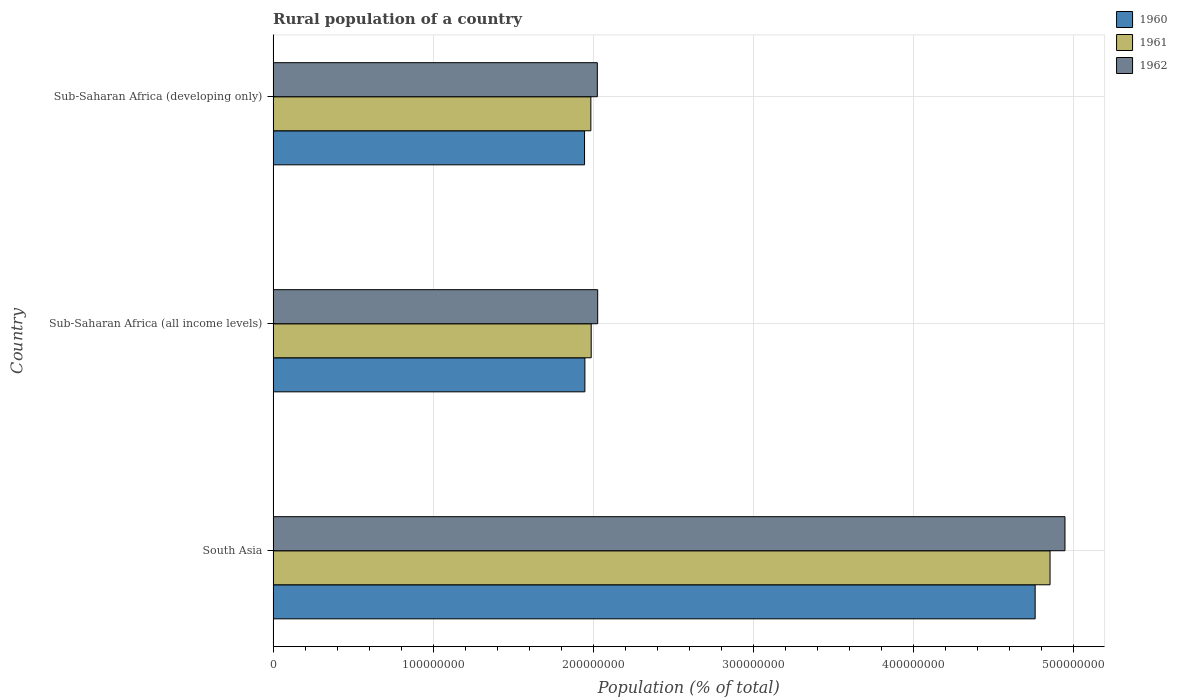How many different coloured bars are there?
Your answer should be very brief. 3. Are the number of bars per tick equal to the number of legend labels?
Offer a terse response. Yes. In how many cases, is the number of bars for a given country not equal to the number of legend labels?
Offer a very short reply. 0. What is the rural population in 1962 in Sub-Saharan Africa (all income levels)?
Keep it short and to the point. 2.03e+08. Across all countries, what is the maximum rural population in 1962?
Give a very brief answer. 4.95e+08. Across all countries, what is the minimum rural population in 1960?
Offer a very short reply. 1.95e+08. In which country was the rural population in 1960 maximum?
Give a very brief answer. South Asia. In which country was the rural population in 1960 minimum?
Your answer should be very brief. Sub-Saharan Africa (developing only). What is the total rural population in 1961 in the graph?
Your answer should be compact. 8.83e+08. What is the difference between the rural population in 1960 in Sub-Saharan Africa (all income levels) and that in Sub-Saharan Africa (developing only)?
Keep it short and to the point. 2.18e+05. What is the difference between the rural population in 1962 in Sub-Saharan Africa (developing only) and the rural population in 1961 in South Asia?
Offer a terse response. -2.83e+08. What is the average rural population in 1962 per country?
Provide a succinct answer. 3.00e+08. What is the difference between the rural population in 1960 and rural population in 1962 in Sub-Saharan Africa (developing only)?
Your response must be concise. -8.00e+06. In how many countries, is the rural population in 1961 greater than 420000000 %?
Offer a terse response. 1. What is the ratio of the rural population in 1960 in South Asia to that in Sub-Saharan Africa (all income levels)?
Make the answer very short. 2.44. What is the difference between the highest and the second highest rural population in 1962?
Keep it short and to the point. 2.92e+08. What is the difference between the highest and the lowest rural population in 1961?
Keep it short and to the point. 2.87e+08. What does the 1st bar from the top in Sub-Saharan Africa (developing only) represents?
Your response must be concise. 1962. What does the 2nd bar from the bottom in Sub-Saharan Africa (all income levels) represents?
Keep it short and to the point. 1961. How many bars are there?
Your response must be concise. 9. Are all the bars in the graph horizontal?
Provide a succinct answer. Yes. Are the values on the major ticks of X-axis written in scientific E-notation?
Your response must be concise. No. Does the graph contain any zero values?
Provide a succinct answer. No. How are the legend labels stacked?
Provide a short and direct response. Vertical. What is the title of the graph?
Your answer should be very brief. Rural population of a country. What is the label or title of the X-axis?
Give a very brief answer. Population (% of total). What is the Population (% of total) of 1960 in South Asia?
Offer a very short reply. 4.76e+08. What is the Population (% of total) of 1961 in South Asia?
Provide a succinct answer. 4.86e+08. What is the Population (% of total) in 1962 in South Asia?
Give a very brief answer. 4.95e+08. What is the Population (% of total) of 1960 in Sub-Saharan Africa (all income levels)?
Give a very brief answer. 1.95e+08. What is the Population (% of total) in 1961 in Sub-Saharan Africa (all income levels)?
Provide a short and direct response. 1.99e+08. What is the Population (% of total) of 1962 in Sub-Saharan Africa (all income levels)?
Keep it short and to the point. 2.03e+08. What is the Population (% of total) in 1960 in Sub-Saharan Africa (developing only)?
Your response must be concise. 1.95e+08. What is the Population (% of total) of 1961 in Sub-Saharan Africa (developing only)?
Your response must be concise. 1.99e+08. What is the Population (% of total) in 1962 in Sub-Saharan Africa (developing only)?
Your answer should be compact. 2.03e+08. Across all countries, what is the maximum Population (% of total) of 1960?
Offer a terse response. 4.76e+08. Across all countries, what is the maximum Population (% of total) in 1961?
Provide a succinct answer. 4.86e+08. Across all countries, what is the maximum Population (% of total) in 1962?
Make the answer very short. 4.95e+08. Across all countries, what is the minimum Population (% of total) of 1960?
Provide a succinct answer. 1.95e+08. Across all countries, what is the minimum Population (% of total) of 1961?
Ensure brevity in your answer.  1.99e+08. Across all countries, what is the minimum Population (% of total) of 1962?
Your answer should be compact. 2.03e+08. What is the total Population (% of total) in 1960 in the graph?
Offer a terse response. 8.66e+08. What is the total Population (% of total) of 1961 in the graph?
Keep it short and to the point. 8.83e+08. What is the total Population (% of total) of 1962 in the graph?
Ensure brevity in your answer.  9.00e+08. What is the difference between the Population (% of total) of 1960 in South Asia and that in Sub-Saharan Africa (all income levels)?
Your answer should be compact. 2.81e+08. What is the difference between the Population (% of total) in 1961 in South Asia and that in Sub-Saharan Africa (all income levels)?
Offer a very short reply. 2.87e+08. What is the difference between the Population (% of total) of 1962 in South Asia and that in Sub-Saharan Africa (all income levels)?
Ensure brevity in your answer.  2.92e+08. What is the difference between the Population (% of total) of 1960 in South Asia and that in Sub-Saharan Africa (developing only)?
Ensure brevity in your answer.  2.82e+08. What is the difference between the Population (% of total) in 1961 in South Asia and that in Sub-Saharan Africa (developing only)?
Provide a succinct answer. 2.87e+08. What is the difference between the Population (% of total) in 1962 in South Asia and that in Sub-Saharan Africa (developing only)?
Provide a short and direct response. 2.92e+08. What is the difference between the Population (% of total) in 1960 in Sub-Saharan Africa (all income levels) and that in Sub-Saharan Africa (developing only)?
Ensure brevity in your answer.  2.18e+05. What is the difference between the Population (% of total) in 1961 in Sub-Saharan Africa (all income levels) and that in Sub-Saharan Africa (developing only)?
Your answer should be compact. 2.19e+05. What is the difference between the Population (% of total) in 1962 in Sub-Saharan Africa (all income levels) and that in Sub-Saharan Africa (developing only)?
Give a very brief answer. 2.21e+05. What is the difference between the Population (% of total) in 1960 in South Asia and the Population (% of total) in 1961 in Sub-Saharan Africa (all income levels)?
Your answer should be very brief. 2.77e+08. What is the difference between the Population (% of total) of 1960 in South Asia and the Population (% of total) of 1962 in Sub-Saharan Africa (all income levels)?
Your answer should be very brief. 2.73e+08. What is the difference between the Population (% of total) of 1961 in South Asia and the Population (% of total) of 1962 in Sub-Saharan Africa (all income levels)?
Offer a terse response. 2.83e+08. What is the difference between the Population (% of total) of 1960 in South Asia and the Population (% of total) of 1961 in Sub-Saharan Africa (developing only)?
Your answer should be very brief. 2.78e+08. What is the difference between the Population (% of total) of 1960 in South Asia and the Population (% of total) of 1962 in Sub-Saharan Africa (developing only)?
Offer a very short reply. 2.74e+08. What is the difference between the Population (% of total) in 1961 in South Asia and the Population (% of total) in 1962 in Sub-Saharan Africa (developing only)?
Make the answer very short. 2.83e+08. What is the difference between the Population (% of total) of 1960 in Sub-Saharan Africa (all income levels) and the Population (% of total) of 1961 in Sub-Saharan Africa (developing only)?
Ensure brevity in your answer.  -3.73e+06. What is the difference between the Population (% of total) in 1960 in Sub-Saharan Africa (all income levels) and the Population (% of total) in 1962 in Sub-Saharan Africa (developing only)?
Give a very brief answer. -7.78e+06. What is the difference between the Population (% of total) of 1961 in Sub-Saharan Africa (all income levels) and the Population (% of total) of 1962 in Sub-Saharan Africa (developing only)?
Your answer should be compact. -3.83e+06. What is the average Population (% of total) of 1960 per country?
Your answer should be very brief. 2.89e+08. What is the average Population (% of total) in 1961 per country?
Offer a terse response. 2.94e+08. What is the average Population (% of total) in 1962 per country?
Give a very brief answer. 3.00e+08. What is the difference between the Population (% of total) in 1960 and Population (% of total) in 1961 in South Asia?
Keep it short and to the point. -9.31e+06. What is the difference between the Population (% of total) in 1960 and Population (% of total) in 1962 in South Asia?
Offer a very short reply. -1.86e+07. What is the difference between the Population (% of total) in 1961 and Population (% of total) in 1962 in South Asia?
Your response must be concise. -9.32e+06. What is the difference between the Population (% of total) of 1960 and Population (% of total) of 1961 in Sub-Saharan Africa (all income levels)?
Give a very brief answer. -3.95e+06. What is the difference between the Population (% of total) in 1960 and Population (% of total) in 1962 in Sub-Saharan Africa (all income levels)?
Ensure brevity in your answer.  -8.00e+06. What is the difference between the Population (% of total) of 1961 and Population (% of total) of 1962 in Sub-Saharan Africa (all income levels)?
Make the answer very short. -4.05e+06. What is the difference between the Population (% of total) in 1960 and Population (% of total) in 1961 in Sub-Saharan Africa (developing only)?
Provide a succinct answer. -3.95e+06. What is the difference between the Population (% of total) of 1960 and Population (% of total) of 1962 in Sub-Saharan Africa (developing only)?
Your answer should be very brief. -8.00e+06. What is the difference between the Population (% of total) in 1961 and Population (% of total) in 1962 in Sub-Saharan Africa (developing only)?
Offer a very short reply. -4.05e+06. What is the ratio of the Population (% of total) of 1960 in South Asia to that in Sub-Saharan Africa (all income levels)?
Provide a succinct answer. 2.44. What is the ratio of the Population (% of total) of 1961 in South Asia to that in Sub-Saharan Africa (all income levels)?
Offer a very short reply. 2.44. What is the ratio of the Population (% of total) of 1962 in South Asia to that in Sub-Saharan Africa (all income levels)?
Make the answer very short. 2.44. What is the ratio of the Population (% of total) in 1960 in South Asia to that in Sub-Saharan Africa (developing only)?
Provide a succinct answer. 2.45. What is the ratio of the Population (% of total) of 1961 in South Asia to that in Sub-Saharan Africa (developing only)?
Provide a short and direct response. 2.45. What is the ratio of the Population (% of total) of 1962 in South Asia to that in Sub-Saharan Africa (developing only)?
Offer a terse response. 2.44. What is the ratio of the Population (% of total) in 1960 in Sub-Saharan Africa (all income levels) to that in Sub-Saharan Africa (developing only)?
Keep it short and to the point. 1. What is the ratio of the Population (% of total) of 1961 in Sub-Saharan Africa (all income levels) to that in Sub-Saharan Africa (developing only)?
Give a very brief answer. 1. What is the ratio of the Population (% of total) in 1962 in Sub-Saharan Africa (all income levels) to that in Sub-Saharan Africa (developing only)?
Keep it short and to the point. 1. What is the difference between the highest and the second highest Population (% of total) of 1960?
Give a very brief answer. 2.81e+08. What is the difference between the highest and the second highest Population (% of total) in 1961?
Keep it short and to the point. 2.87e+08. What is the difference between the highest and the second highest Population (% of total) in 1962?
Make the answer very short. 2.92e+08. What is the difference between the highest and the lowest Population (% of total) of 1960?
Offer a terse response. 2.82e+08. What is the difference between the highest and the lowest Population (% of total) of 1961?
Give a very brief answer. 2.87e+08. What is the difference between the highest and the lowest Population (% of total) in 1962?
Offer a very short reply. 2.92e+08. 